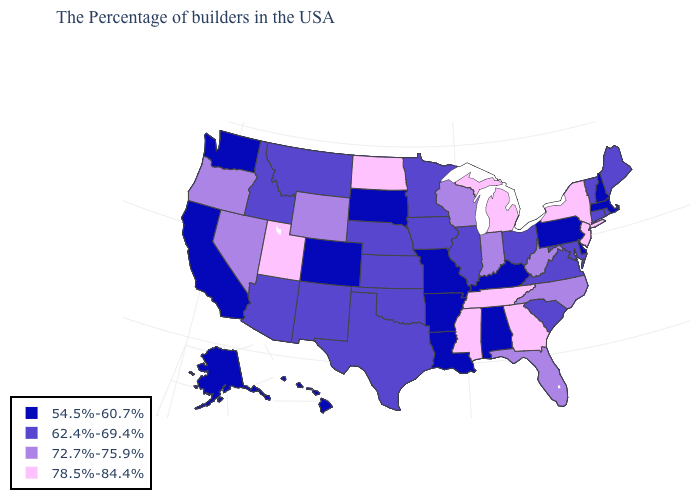What is the value of Connecticut?
Short answer required. 62.4%-69.4%. What is the value of Utah?
Be succinct. 78.5%-84.4%. What is the value of Kentucky?
Keep it brief. 54.5%-60.7%. Name the states that have a value in the range 54.5%-60.7%?
Concise answer only. Massachusetts, New Hampshire, Delaware, Pennsylvania, Kentucky, Alabama, Louisiana, Missouri, Arkansas, South Dakota, Colorado, California, Washington, Alaska, Hawaii. Among the states that border Tennessee , does Georgia have the lowest value?
Answer briefly. No. Name the states that have a value in the range 54.5%-60.7%?
Write a very short answer. Massachusetts, New Hampshire, Delaware, Pennsylvania, Kentucky, Alabama, Louisiana, Missouri, Arkansas, South Dakota, Colorado, California, Washington, Alaska, Hawaii. What is the highest value in the South ?
Answer briefly. 78.5%-84.4%. Which states have the lowest value in the South?
Keep it brief. Delaware, Kentucky, Alabama, Louisiana, Arkansas. Name the states that have a value in the range 78.5%-84.4%?
Concise answer only. New York, New Jersey, Georgia, Michigan, Tennessee, Mississippi, North Dakota, Utah. What is the value of Kentucky?
Be succinct. 54.5%-60.7%. Which states hav the highest value in the Northeast?
Be succinct. New York, New Jersey. What is the value of Mississippi?
Write a very short answer. 78.5%-84.4%. Does the map have missing data?
Short answer required. No. Among the states that border Arkansas , which have the highest value?
Short answer required. Tennessee, Mississippi. Name the states that have a value in the range 54.5%-60.7%?
Quick response, please. Massachusetts, New Hampshire, Delaware, Pennsylvania, Kentucky, Alabama, Louisiana, Missouri, Arkansas, South Dakota, Colorado, California, Washington, Alaska, Hawaii. 